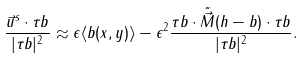Convert formula to latex. <formula><loc_0><loc_0><loc_500><loc_500>\frac { \vec { u } ^ { s } \cdot \tau b } { | \tau b | ^ { 2 } } \approx \epsilon \langle b ( x , y ) \rangle - \epsilon ^ { 2 } \frac { \tau b \cdot \tilde { \vec { M } } ( h - b ) \cdot \tau b } { | \tau b | ^ { 2 } } .</formula> 